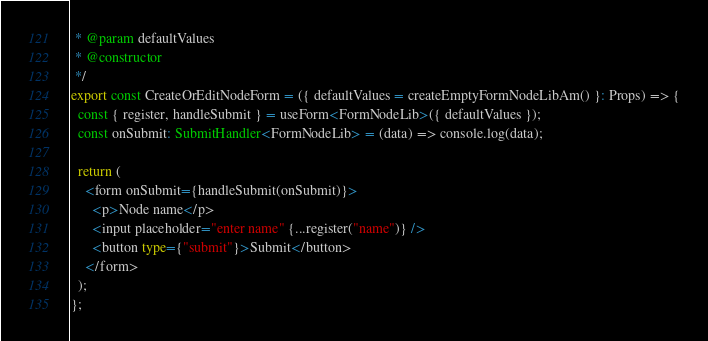Convert code to text. <code><loc_0><loc_0><loc_500><loc_500><_TypeScript_> * @param defaultValues
 * @constructor
 */
export const CreateOrEditNodeForm = ({ defaultValues = createEmptyFormNodeLibAm() }: Props) => {
  const { register, handleSubmit } = useForm<FormNodeLib>({ defaultValues });
  const onSubmit: SubmitHandler<FormNodeLib> = (data) => console.log(data);

  return (
    <form onSubmit={handleSubmit(onSubmit)}>
      <p>Node name</p>
      <input placeholder="enter name" {...register("name")} />
      <button type={"submit"}>Submit</button>
    </form>
  );
};
</code> 